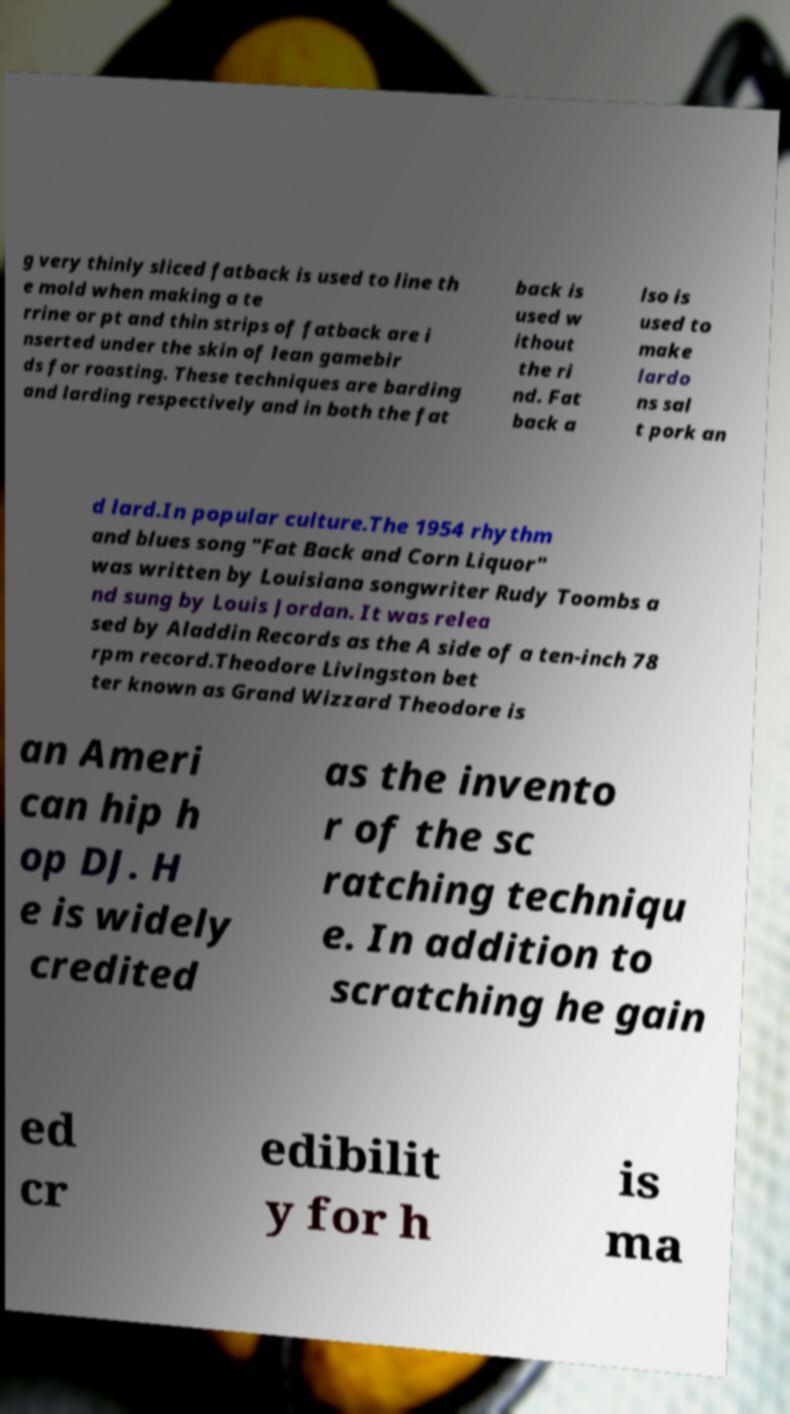Can you accurately transcribe the text from the provided image for me? g very thinly sliced fatback is used to line th e mold when making a te rrine or pt and thin strips of fatback are i nserted under the skin of lean gamebir ds for roasting. These techniques are barding and larding respectively and in both the fat back is used w ithout the ri nd. Fat back a lso is used to make lardo ns sal t pork an d lard.In popular culture.The 1954 rhythm and blues song "Fat Back and Corn Liquor" was written by Louisiana songwriter Rudy Toombs a nd sung by Louis Jordan. It was relea sed by Aladdin Records as the A side of a ten-inch 78 rpm record.Theodore Livingston bet ter known as Grand Wizzard Theodore is an Ameri can hip h op DJ. H e is widely credited as the invento r of the sc ratching techniqu e. In addition to scratching he gain ed cr edibilit y for h is ma 